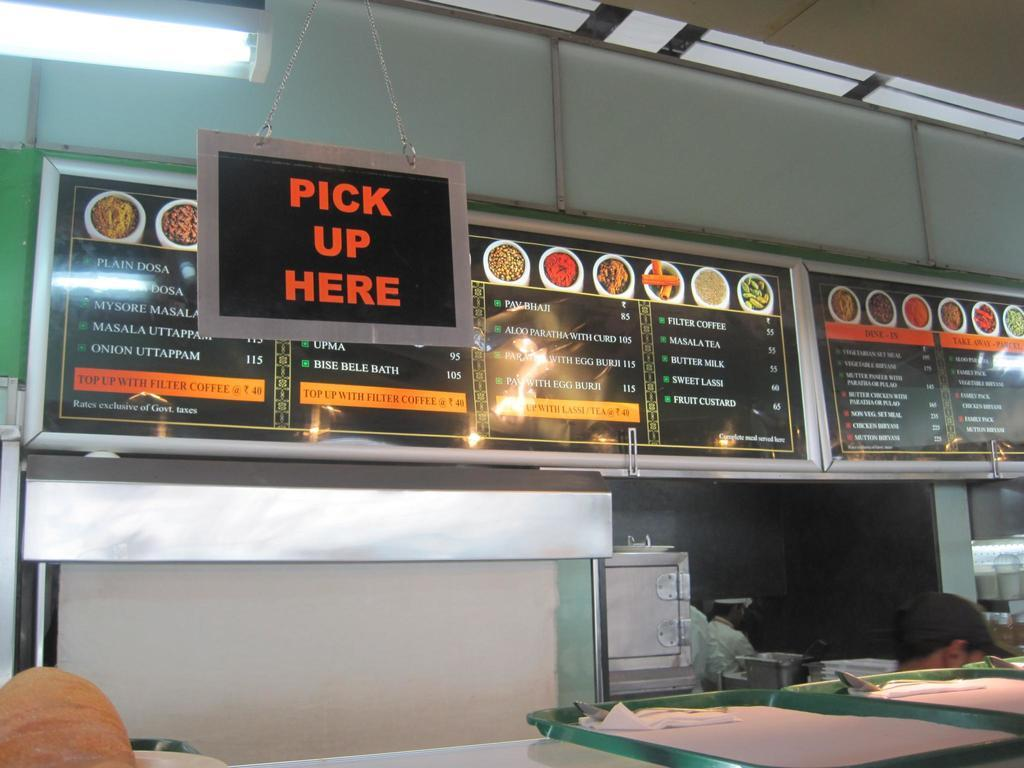What type of furniture is in the image? There is a table in the image. What is placed on the table? There are trays, tissue papers, and spoons on the table. What type of containers can be seen in the image? Bowls are observable in the image. What objects are present in the image that might be used for communication or display? Boards are present in the image. What can be used as a source of illumination in the image? There is a light source in the image. Are there any people present in the image? Yes, there are persons in the image. What type of creature is using its tongue to interact with the objects on the table in the image? There is no creature present in the image, and therefore no such interaction can be observed. --- Facts: 1. There is a car in the image. 2. The car is red. 3. The car has four wheels. 4. There are people in the car. 5. The car has a roof. 6. The car has a trunk. Absurd Topics: bird, ocean, mountain Conversation: What type of vehicle is in the image? There is a car in the image. What color is the car? The car is red. How many wheels does the car have? The car has four wheels. Are there any passengers in the car? Yes, there are people in the car. What type of covering does the car have on top? The car has a roof. What type of storage is available in the car? The car has a trunk. Reasoning: Let's think step by step in order to produce the conversation. We start by identifying the main subject of the image, which is the car. Next, we describe specific features of the car, such as its color, the number of wheels, and the presence of passengers. We also mention the car's roof and trunk, which are important parts of a car. Absurd Question/Answer: Can you see any birds flying over the car in the image? No, there are no birds visible in the image. 